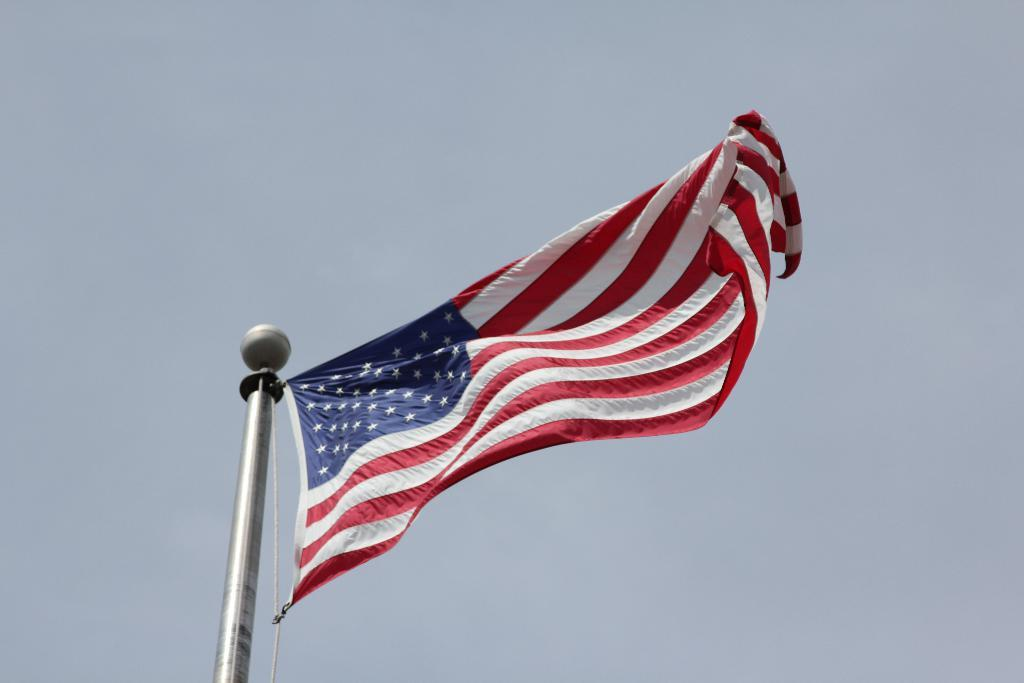What is the main object in the image? There is a flag in the image. Where is the flag located? The flag is on top of a pole. How many homes are visible in the image? There is no home visible in the image; it only features a flag on a pole. What type of attack is being depicted in the image? There is no attack depicted in the image; it only features a flag on a pole. 